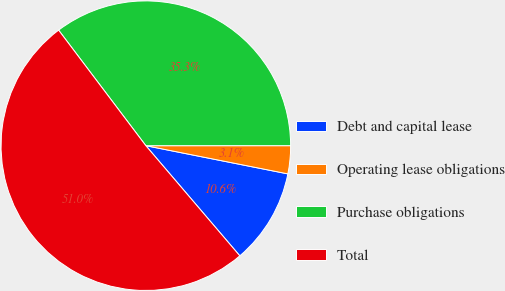Convert chart. <chart><loc_0><loc_0><loc_500><loc_500><pie_chart><fcel>Debt and capital lease<fcel>Operating lease obligations<fcel>Purchase obligations<fcel>Total<nl><fcel>10.64%<fcel>3.12%<fcel>35.29%<fcel>50.95%<nl></chart> 